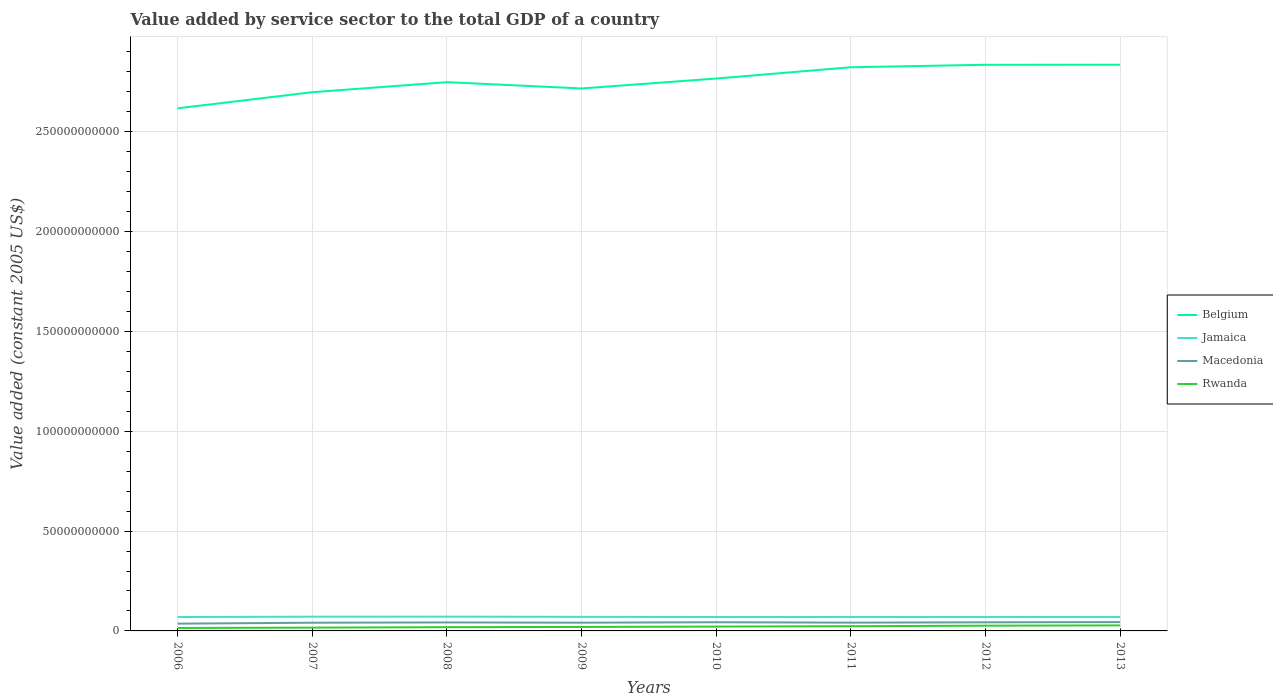Does the line corresponding to Rwanda intersect with the line corresponding to Jamaica?
Offer a very short reply. No. Across all years, what is the maximum value added by service sector in Macedonia?
Make the answer very short. 3.65e+09. In which year was the value added by service sector in Rwanda maximum?
Make the answer very short. 2006. What is the total value added by service sector in Belgium in the graph?
Ensure brevity in your answer.  -1.81e+09. What is the difference between the highest and the second highest value added by service sector in Belgium?
Offer a very short reply. 2.18e+1. What is the difference between two consecutive major ticks on the Y-axis?
Provide a succinct answer. 5.00e+1. Are the values on the major ticks of Y-axis written in scientific E-notation?
Offer a very short reply. No. Does the graph contain grids?
Offer a terse response. Yes. Where does the legend appear in the graph?
Your answer should be very brief. Center right. How many legend labels are there?
Make the answer very short. 4. How are the legend labels stacked?
Your response must be concise. Vertical. What is the title of the graph?
Your response must be concise. Value added by service sector to the total GDP of a country. Does "Least developed countries" appear as one of the legend labels in the graph?
Your response must be concise. No. What is the label or title of the Y-axis?
Make the answer very short. Value added (constant 2005 US$). What is the Value added (constant 2005 US$) of Belgium in 2006?
Offer a terse response. 2.62e+11. What is the Value added (constant 2005 US$) in Jamaica in 2006?
Provide a succinct answer. 6.97e+09. What is the Value added (constant 2005 US$) in Macedonia in 2006?
Keep it short and to the point. 3.65e+09. What is the Value added (constant 2005 US$) in Rwanda in 2006?
Make the answer very short. 1.47e+09. What is the Value added (constant 2005 US$) in Belgium in 2007?
Your answer should be compact. 2.70e+11. What is the Value added (constant 2005 US$) in Jamaica in 2007?
Keep it short and to the point. 7.12e+09. What is the Value added (constant 2005 US$) of Macedonia in 2007?
Your answer should be very brief. 4.11e+09. What is the Value added (constant 2005 US$) of Rwanda in 2007?
Ensure brevity in your answer.  1.65e+09. What is the Value added (constant 2005 US$) in Belgium in 2008?
Ensure brevity in your answer.  2.75e+11. What is the Value added (constant 2005 US$) of Jamaica in 2008?
Make the answer very short. 7.15e+09. What is the Value added (constant 2005 US$) in Macedonia in 2008?
Your answer should be very brief. 4.25e+09. What is the Value added (constant 2005 US$) in Rwanda in 2008?
Your answer should be very brief. 1.88e+09. What is the Value added (constant 2005 US$) of Belgium in 2009?
Ensure brevity in your answer.  2.72e+11. What is the Value added (constant 2005 US$) of Jamaica in 2009?
Your response must be concise. 7.05e+09. What is the Value added (constant 2005 US$) of Macedonia in 2009?
Offer a terse response. 4.13e+09. What is the Value added (constant 2005 US$) of Rwanda in 2009?
Make the answer very short. 1.99e+09. What is the Value added (constant 2005 US$) in Belgium in 2010?
Provide a succinct answer. 2.77e+11. What is the Value added (constant 2005 US$) in Jamaica in 2010?
Your response must be concise. 6.98e+09. What is the Value added (constant 2005 US$) in Macedonia in 2010?
Ensure brevity in your answer.  4.34e+09. What is the Value added (constant 2005 US$) of Rwanda in 2010?
Your response must be concise. 2.17e+09. What is the Value added (constant 2005 US$) in Belgium in 2011?
Your answer should be very brief. 2.82e+11. What is the Value added (constant 2005 US$) of Jamaica in 2011?
Give a very brief answer. 7.00e+09. What is the Value added (constant 2005 US$) in Macedonia in 2011?
Offer a terse response. 4.15e+09. What is the Value added (constant 2005 US$) of Rwanda in 2011?
Provide a succinct answer. 2.35e+09. What is the Value added (constant 2005 US$) of Belgium in 2012?
Your response must be concise. 2.83e+11. What is the Value added (constant 2005 US$) of Jamaica in 2012?
Offer a terse response. 6.99e+09. What is the Value added (constant 2005 US$) of Macedonia in 2012?
Offer a terse response. 4.30e+09. What is the Value added (constant 2005 US$) of Rwanda in 2012?
Your answer should be very brief. 2.63e+09. What is the Value added (constant 2005 US$) of Belgium in 2013?
Provide a succinct answer. 2.84e+11. What is the Value added (constant 2005 US$) of Jamaica in 2013?
Provide a succinct answer. 7.01e+09. What is the Value added (constant 2005 US$) in Macedonia in 2013?
Ensure brevity in your answer.  4.42e+09. What is the Value added (constant 2005 US$) of Rwanda in 2013?
Provide a succinct answer. 2.76e+09. Across all years, what is the maximum Value added (constant 2005 US$) of Belgium?
Ensure brevity in your answer.  2.84e+11. Across all years, what is the maximum Value added (constant 2005 US$) in Jamaica?
Give a very brief answer. 7.15e+09. Across all years, what is the maximum Value added (constant 2005 US$) of Macedonia?
Your answer should be very brief. 4.42e+09. Across all years, what is the maximum Value added (constant 2005 US$) of Rwanda?
Ensure brevity in your answer.  2.76e+09. Across all years, what is the minimum Value added (constant 2005 US$) in Belgium?
Your answer should be very brief. 2.62e+11. Across all years, what is the minimum Value added (constant 2005 US$) in Jamaica?
Offer a terse response. 6.97e+09. Across all years, what is the minimum Value added (constant 2005 US$) of Macedonia?
Make the answer very short. 3.65e+09. Across all years, what is the minimum Value added (constant 2005 US$) of Rwanda?
Your answer should be compact. 1.47e+09. What is the total Value added (constant 2005 US$) of Belgium in the graph?
Give a very brief answer. 2.20e+12. What is the total Value added (constant 2005 US$) in Jamaica in the graph?
Make the answer very short. 5.63e+1. What is the total Value added (constant 2005 US$) in Macedonia in the graph?
Ensure brevity in your answer.  3.34e+1. What is the total Value added (constant 2005 US$) of Rwanda in the graph?
Keep it short and to the point. 1.69e+1. What is the difference between the Value added (constant 2005 US$) of Belgium in 2006 and that in 2007?
Make the answer very short. -8.08e+09. What is the difference between the Value added (constant 2005 US$) of Jamaica in 2006 and that in 2007?
Your answer should be very brief. -1.55e+08. What is the difference between the Value added (constant 2005 US$) of Macedonia in 2006 and that in 2007?
Offer a terse response. -4.63e+08. What is the difference between the Value added (constant 2005 US$) in Rwanda in 2006 and that in 2007?
Provide a short and direct response. -1.78e+08. What is the difference between the Value added (constant 2005 US$) of Belgium in 2006 and that in 2008?
Your response must be concise. -1.31e+1. What is the difference between the Value added (constant 2005 US$) of Jamaica in 2006 and that in 2008?
Keep it short and to the point. -1.85e+08. What is the difference between the Value added (constant 2005 US$) in Macedonia in 2006 and that in 2008?
Provide a succinct answer. -6.05e+08. What is the difference between the Value added (constant 2005 US$) in Rwanda in 2006 and that in 2008?
Offer a very short reply. -4.03e+08. What is the difference between the Value added (constant 2005 US$) in Belgium in 2006 and that in 2009?
Give a very brief answer. -9.95e+09. What is the difference between the Value added (constant 2005 US$) in Jamaica in 2006 and that in 2009?
Offer a terse response. -8.30e+07. What is the difference between the Value added (constant 2005 US$) of Macedonia in 2006 and that in 2009?
Keep it short and to the point. -4.86e+08. What is the difference between the Value added (constant 2005 US$) in Rwanda in 2006 and that in 2009?
Keep it short and to the point. -5.18e+08. What is the difference between the Value added (constant 2005 US$) in Belgium in 2006 and that in 2010?
Make the answer very short. -1.49e+1. What is the difference between the Value added (constant 2005 US$) of Jamaica in 2006 and that in 2010?
Keep it short and to the point. -1.06e+07. What is the difference between the Value added (constant 2005 US$) of Macedonia in 2006 and that in 2010?
Ensure brevity in your answer.  -6.92e+08. What is the difference between the Value added (constant 2005 US$) in Rwanda in 2006 and that in 2010?
Your answer should be very brief. -7.00e+08. What is the difference between the Value added (constant 2005 US$) in Belgium in 2006 and that in 2011?
Keep it short and to the point. -2.06e+1. What is the difference between the Value added (constant 2005 US$) of Jamaica in 2006 and that in 2011?
Your response must be concise. -2.85e+07. What is the difference between the Value added (constant 2005 US$) of Macedonia in 2006 and that in 2011?
Offer a terse response. -4.98e+08. What is the difference between the Value added (constant 2005 US$) in Rwanda in 2006 and that in 2011?
Offer a terse response. -8.80e+08. What is the difference between the Value added (constant 2005 US$) in Belgium in 2006 and that in 2012?
Make the answer very short. -2.18e+1. What is the difference between the Value added (constant 2005 US$) of Jamaica in 2006 and that in 2012?
Offer a terse response. -2.44e+07. What is the difference between the Value added (constant 2005 US$) of Macedonia in 2006 and that in 2012?
Your answer should be compact. -6.55e+08. What is the difference between the Value added (constant 2005 US$) of Rwanda in 2006 and that in 2012?
Offer a terse response. -1.15e+09. What is the difference between the Value added (constant 2005 US$) in Belgium in 2006 and that in 2013?
Provide a short and direct response. -2.18e+1. What is the difference between the Value added (constant 2005 US$) in Jamaica in 2006 and that in 2013?
Offer a very short reply. -3.92e+07. What is the difference between the Value added (constant 2005 US$) of Macedonia in 2006 and that in 2013?
Your answer should be very brief. -7.69e+08. What is the difference between the Value added (constant 2005 US$) in Rwanda in 2006 and that in 2013?
Give a very brief answer. -1.29e+09. What is the difference between the Value added (constant 2005 US$) of Belgium in 2007 and that in 2008?
Offer a very short reply. -5.02e+09. What is the difference between the Value added (constant 2005 US$) in Jamaica in 2007 and that in 2008?
Offer a terse response. -2.92e+07. What is the difference between the Value added (constant 2005 US$) of Macedonia in 2007 and that in 2008?
Offer a very short reply. -1.43e+08. What is the difference between the Value added (constant 2005 US$) in Rwanda in 2007 and that in 2008?
Your answer should be very brief. -2.25e+08. What is the difference between the Value added (constant 2005 US$) of Belgium in 2007 and that in 2009?
Make the answer very short. -1.87e+09. What is the difference between the Value added (constant 2005 US$) in Jamaica in 2007 and that in 2009?
Your answer should be compact. 7.25e+07. What is the difference between the Value added (constant 2005 US$) in Macedonia in 2007 and that in 2009?
Ensure brevity in your answer.  -2.30e+07. What is the difference between the Value added (constant 2005 US$) in Rwanda in 2007 and that in 2009?
Give a very brief answer. -3.41e+08. What is the difference between the Value added (constant 2005 US$) of Belgium in 2007 and that in 2010?
Keep it short and to the point. -6.84e+09. What is the difference between the Value added (constant 2005 US$) in Jamaica in 2007 and that in 2010?
Your answer should be very brief. 1.45e+08. What is the difference between the Value added (constant 2005 US$) of Macedonia in 2007 and that in 2010?
Provide a succinct answer. -2.29e+08. What is the difference between the Value added (constant 2005 US$) of Rwanda in 2007 and that in 2010?
Provide a succinct answer. -5.22e+08. What is the difference between the Value added (constant 2005 US$) in Belgium in 2007 and that in 2011?
Your answer should be very brief. -1.25e+1. What is the difference between the Value added (constant 2005 US$) in Jamaica in 2007 and that in 2011?
Your answer should be very brief. 1.27e+08. What is the difference between the Value added (constant 2005 US$) in Macedonia in 2007 and that in 2011?
Offer a terse response. -3.58e+07. What is the difference between the Value added (constant 2005 US$) in Rwanda in 2007 and that in 2011?
Your response must be concise. -7.03e+08. What is the difference between the Value added (constant 2005 US$) in Belgium in 2007 and that in 2012?
Make the answer very short. -1.37e+1. What is the difference between the Value added (constant 2005 US$) in Jamaica in 2007 and that in 2012?
Provide a short and direct response. 1.31e+08. What is the difference between the Value added (constant 2005 US$) in Macedonia in 2007 and that in 2012?
Provide a succinct answer. -1.93e+08. What is the difference between the Value added (constant 2005 US$) in Rwanda in 2007 and that in 2012?
Offer a very short reply. -9.75e+08. What is the difference between the Value added (constant 2005 US$) of Belgium in 2007 and that in 2013?
Give a very brief answer. -1.38e+1. What is the difference between the Value added (constant 2005 US$) of Jamaica in 2007 and that in 2013?
Offer a terse response. 1.16e+08. What is the difference between the Value added (constant 2005 US$) of Macedonia in 2007 and that in 2013?
Offer a very short reply. -3.06e+08. What is the difference between the Value added (constant 2005 US$) in Rwanda in 2007 and that in 2013?
Your answer should be compact. -1.11e+09. What is the difference between the Value added (constant 2005 US$) in Belgium in 2008 and that in 2009?
Provide a short and direct response. 3.15e+09. What is the difference between the Value added (constant 2005 US$) of Jamaica in 2008 and that in 2009?
Provide a succinct answer. 1.02e+08. What is the difference between the Value added (constant 2005 US$) of Macedonia in 2008 and that in 2009?
Keep it short and to the point. 1.20e+08. What is the difference between the Value added (constant 2005 US$) of Rwanda in 2008 and that in 2009?
Offer a very short reply. -1.16e+08. What is the difference between the Value added (constant 2005 US$) in Belgium in 2008 and that in 2010?
Provide a short and direct response. -1.81e+09. What is the difference between the Value added (constant 2005 US$) of Jamaica in 2008 and that in 2010?
Your answer should be compact. 1.74e+08. What is the difference between the Value added (constant 2005 US$) of Macedonia in 2008 and that in 2010?
Offer a very short reply. -8.65e+07. What is the difference between the Value added (constant 2005 US$) of Rwanda in 2008 and that in 2010?
Offer a very short reply. -2.97e+08. What is the difference between the Value added (constant 2005 US$) of Belgium in 2008 and that in 2011?
Your response must be concise. -7.47e+09. What is the difference between the Value added (constant 2005 US$) in Jamaica in 2008 and that in 2011?
Your answer should be very brief. 1.56e+08. What is the difference between the Value added (constant 2005 US$) of Macedonia in 2008 and that in 2011?
Provide a succinct answer. 1.07e+08. What is the difference between the Value added (constant 2005 US$) of Rwanda in 2008 and that in 2011?
Offer a terse response. -4.78e+08. What is the difference between the Value added (constant 2005 US$) of Belgium in 2008 and that in 2012?
Keep it short and to the point. -8.71e+09. What is the difference between the Value added (constant 2005 US$) of Jamaica in 2008 and that in 2012?
Provide a succinct answer. 1.60e+08. What is the difference between the Value added (constant 2005 US$) of Macedonia in 2008 and that in 2012?
Your answer should be compact. -5.01e+07. What is the difference between the Value added (constant 2005 US$) in Rwanda in 2008 and that in 2012?
Offer a very short reply. -7.50e+08. What is the difference between the Value added (constant 2005 US$) of Belgium in 2008 and that in 2013?
Make the answer very short. -8.73e+09. What is the difference between the Value added (constant 2005 US$) in Jamaica in 2008 and that in 2013?
Give a very brief answer. 1.45e+08. What is the difference between the Value added (constant 2005 US$) of Macedonia in 2008 and that in 2013?
Your response must be concise. -1.63e+08. What is the difference between the Value added (constant 2005 US$) of Rwanda in 2008 and that in 2013?
Your answer should be compact. -8.87e+08. What is the difference between the Value added (constant 2005 US$) of Belgium in 2009 and that in 2010?
Provide a short and direct response. -4.96e+09. What is the difference between the Value added (constant 2005 US$) in Jamaica in 2009 and that in 2010?
Your response must be concise. 7.23e+07. What is the difference between the Value added (constant 2005 US$) of Macedonia in 2009 and that in 2010?
Your response must be concise. -2.06e+08. What is the difference between the Value added (constant 2005 US$) in Rwanda in 2009 and that in 2010?
Provide a short and direct response. -1.82e+08. What is the difference between the Value added (constant 2005 US$) in Belgium in 2009 and that in 2011?
Offer a terse response. -1.06e+1. What is the difference between the Value added (constant 2005 US$) in Jamaica in 2009 and that in 2011?
Give a very brief answer. 5.44e+07. What is the difference between the Value added (constant 2005 US$) in Macedonia in 2009 and that in 2011?
Give a very brief answer. -1.28e+07. What is the difference between the Value added (constant 2005 US$) of Rwanda in 2009 and that in 2011?
Keep it short and to the point. -3.62e+08. What is the difference between the Value added (constant 2005 US$) in Belgium in 2009 and that in 2012?
Provide a succinct answer. -1.19e+1. What is the difference between the Value added (constant 2005 US$) in Jamaica in 2009 and that in 2012?
Offer a terse response. 5.85e+07. What is the difference between the Value added (constant 2005 US$) of Macedonia in 2009 and that in 2012?
Ensure brevity in your answer.  -1.70e+08. What is the difference between the Value added (constant 2005 US$) of Rwanda in 2009 and that in 2012?
Make the answer very short. -6.34e+08. What is the difference between the Value added (constant 2005 US$) in Belgium in 2009 and that in 2013?
Your answer should be very brief. -1.19e+1. What is the difference between the Value added (constant 2005 US$) in Jamaica in 2009 and that in 2013?
Your response must be concise. 4.37e+07. What is the difference between the Value added (constant 2005 US$) in Macedonia in 2009 and that in 2013?
Ensure brevity in your answer.  -2.83e+08. What is the difference between the Value added (constant 2005 US$) of Rwanda in 2009 and that in 2013?
Offer a very short reply. -7.71e+08. What is the difference between the Value added (constant 2005 US$) in Belgium in 2010 and that in 2011?
Make the answer very short. -5.66e+09. What is the difference between the Value added (constant 2005 US$) in Jamaica in 2010 and that in 2011?
Keep it short and to the point. -1.79e+07. What is the difference between the Value added (constant 2005 US$) of Macedonia in 2010 and that in 2011?
Ensure brevity in your answer.  1.93e+08. What is the difference between the Value added (constant 2005 US$) of Rwanda in 2010 and that in 2011?
Provide a succinct answer. -1.80e+08. What is the difference between the Value added (constant 2005 US$) of Belgium in 2010 and that in 2012?
Your response must be concise. -6.89e+09. What is the difference between the Value added (constant 2005 US$) of Jamaica in 2010 and that in 2012?
Provide a succinct answer. -1.38e+07. What is the difference between the Value added (constant 2005 US$) of Macedonia in 2010 and that in 2012?
Make the answer very short. 3.64e+07. What is the difference between the Value added (constant 2005 US$) in Rwanda in 2010 and that in 2012?
Provide a succinct answer. -4.53e+08. What is the difference between the Value added (constant 2005 US$) in Belgium in 2010 and that in 2013?
Your response must be concise. -6.91e+09. What is the difference between the Value added (constant 2005 US$) in Jamaica in 2010 and that in 2013?
Your response must be concise. -2.86e+07. What is the difference between the Value added (constant 2005 US$) of Macedonia in 2010 and that in 2013?
Keep it short and to the point. -7.68e+07. What is the difference between the Value added (constant 2005 US$) of Rwanda in 2010 and that in 2013?
Your answer should be compact. -5.89e+08. What is the difference between the Value added (constant 2005 US$) in Belgium in 2011 and that in 2012?
Offer a very short reply. -1.23e+09. What is the difference between the Value added (constant 2005 US$) of Jamaica in 2011 and that in 2012?
Make the answer very short. 4.11e+06. What is the difference between the Value added (constant 2005 US$) of Macedonia in 2011 and that in 2012?
Keep it short and to the point. -1.57e+08. What is the difference between the Value added (constant 2005 US$) in Rwanda in 2011 and that in 2012?
Ensure brevity in your answer.  -2.72e+08. What is the difference between the Value added (constant 2005 US$) in Belgium in 2011 and that in 2013?
Offer a very short reply. -1.25e+09. What is the difference between the Value added (constant 2005 US$) of Jamaica in 2011 and that in 2013?
Provide a short and direct response. -1.07e+07. What is the difference between the Value added (constant 2005 US$) in Macedonia in 2011 and that in 2013?
Your response must be concise. -2.70e+08. What is the difference between the Value added (constant 2005 US$) in Rwanda in 2011 and that in 2013?
Your answer should be very brief. -4.09e+08. What is the difference between the Value added (constant 2005 US$) in Belgium in 2012 and that in 2013?
Provide a short and direct response. -2.04e+07. What is the difference between the Value added (constant 2005 US$) of Jamaica in 2012 and that in 2013?
Your response must be concise. -1.48e+07. What is the difference between the Value added (constant 2005 US$) of Macedonia in 2012 and that in 2013?
Ensure brevity in your answer.  -1.13e+08. What is the difference between the Value added (constant 2005 US$) of Rwanda in 2012 and that in 2013?
Your response must be concise. -1.37e+08. What is the difference between the Value added (constant 2005 US$) of Belgium in 2006 and the Value added (constant 2005 US$) of Jamaica in 2007?
Offer a very short reply. 2.55e+11. What is the difference between the Value added (constant 2005 US$) of Belgium in 2006 and the Value added (constant 2005 US$) of Macedonia in 2007?
Offer a terse response. 2.58e+11. What is the difference between the Value added (constant 2005 US$) of Belgium in 2006 and the Value added (constant 2005 US$) of Rwanda in 2007?
Keep it short and to the point. 2.60e+11. What is the difference between the Value added (constant 2005 US$) in Jamaica in 2006 and the Value added (constant 2005 US$) in Macedonia in 2007?
Your response must be concise. 2.86e+09. What is the difference between the Value added (constant 2005 US$) of Jamaica in 2006 and the Value added (constant 2005 US$) of Rwanda in 2007?
Give a very brief answer. 5.32e+09. What is the difference between the Value added (constant 2005 US$) in Macedonia in 2006 and the Value added (constant 2005 US$) in Rwanda in 2007?
Make the answer very short. 2.00e+09. What is the difference between the Value added (constant 2005 US$) of Belgium in 2006 and the Value added (constant 2005 US$) of Jamaica in 2008?
Make the answer very short. 2.55e+11. What is the difference between the Value added (constant 2005 US$) of Belgium in 2006 and the Value added (constant 2005 US$) of Macedonia in 2008?
Offer a terse response. 2.57e+11. What is the difference between the Value added (constant 2005 US$) in Belgium in 2006 and the Value added (constant 2005 US$) in Rwanda in 2008?
Offer a terse response. 2.60e+11. What is the difference between the Value added (constant 2005 US$) of Jamaica in 2006 and the Value added (constant 2005 US$) of Macedonia in 2008?
Your answer should be very brief. 2.72e+09. What is the difference between the Value added (constant 2005 US$) in Jamaica in 2006 and the Value added (constant 2005 US$) in Rwanda in 2008?
Provide a succinct answer. 5.09e+09. What is the difference between the Value added (constant 2005 US$) in Macedonia in 2006 and the Value added (constant 2005 US$) in Rwanda in 2008?
Offer a very short reply. 1.77e+09. What is the difference between the Value added (constant 2005 US$) of Belgium in 2006 and the Value added (constant 2005 US$) of Jamaica in 2009?
Offer a very short reply. 2.55e+11. What is the difference between the Value added (constant 2005 US$) in Belgium in 2006 and the Value added (constant 2005 US$) in Macedonia in 2009?
Keep it short and to the point. 2.58e+11. What is the difference between the Value added (constant 2005 US$) of Belgium in 2006 and the Value added (constant 2005 US$) of Rwanda in 2009?
Offer a terse response. 2.60e+11. What is the difference between the Value added (constant 2005 US$) in Jamaica in 2006 and the Value added (constant 2005 US$) in Macedonia in 2009?
Keep it short and to the point. 2.84e+09. What is the difference between the Value added (constant 2005 US$) in Jamaica in 2006 and the Value added (constant 2005 US$) in Rwanda in 2009?
Give a very brief answer. 4.98e+09. What is the difference between the Value added (constant 2005 US$) in Macedonia in 2006 and the Value added (constant 2005 US$) in Rwanda in 2009?
Make the answer very short. 1.65e+09. What is the difference between the Value added (constant 2005 US$) in Belgium in 2006 and the Value added (constant 2005 US$) in Jamaica in 2010?
Offer a terse response. 2.55e+11. What is the difference between the Value added (constant 2005 US$) in Belgium in 2006 and the Value added (constant 2005 US$) in Macedonia in 2010?
Your answer should be very brief. 2.57e+11. What is the difference between the Value added (constant 2005 US$) in Belgium in 2006 and the Value added (constant 2005 US$) in Rwanda in 2010?
Offer a very short reply. 2.60e+11. What is the difference between the Value added (constant 2005 US$) in Jamaica in 2006 and the Value added (constant 2005 US$) in Macedonia in 2010?
Keep it short and to the point. 2.63e+09. What is the difference between the Value added (constant 2005 US$) in Jamaica in 2006 and the Value added (constant 2005 US$) in Rwanda in 2010?
Offer a very short reply. 4.79e+09. What is the difference between the Value added (constant 2005 US$) of Macedonia in 2006 and the Value added (constant 2005 US$) of Rwanda in 2010?
Give a very brief answer. 1.47e+09. What is the difference between the Value added (constant 2005 US$) in Belgium in 2006 and the Value added (constant 2005 US$) in Jamaica in 2011?
Give a very brief answer. 2.55e+11. What is the difference between the Value added (constant 2005 US$) in Belgium in 2006 and the Value added (constant 2005 US$) in Macedonia in 2011?
Provide a short and direct response. 2.58e+11. What is the difference between the Value added (constant 2005 US$) of Belgium in 2006 and the Value added (constant 2005 US$) of Rwanda in 2011?
Your answer should be very brief. 2.59e+11. What is the difference between the Value added (constant 2005 US$) in Jamaica in 2006 and the Value added (constant 2005 US$) in Macedonia in 2011?
Ensure brevity in your answer.  2.82e+09. What is the difference between the Value added (constant 2005 US$) of Jamaica in 2006 and the Value added (constant 2005 US$) of Rwanda in 2011?
Offer a very short reply. 4.61e+09. What is the difference between the Value added (constant 2005 US$) in Macedonia in 2006 and the Value added (constant 2005 US$) in Rwanda in 2011?
Your answer should be very brief. 1.29e+09. What is the difference between the Value added (constant 2005 US$) in Belgium in 2006 and the Value added (constant 2005 US$) in Jamaica in 2012?
Your response must be concise. 2.55e+11. What is the difference between the Value added (constant 2005 US$) in Belgium in 2006 and the Value added (constant 2005 US$) in Macedonia in 2012?
Keep it short and to the point. 2.57e+11. What is the difference between the Value added (constant 2005 US$) in Belgium in 2006 and the Value added (constant 2005 US$) in Rwanda in 2012?
Provide a succinct answer. 2.59e+11. What is the difference between the Value added (constant 2005 US$) of Jamaica in 2006 and the Value added (constant 2005 US$) of Macedonia in 2012?
Ensure brevity in your answer.  2.67e+09. What is the difference between the Value added (constant 2005 US$) of Jamaica in 2006 and the Value added (constant 2005 US$) of Rwanda in 2012?
Ensure brevity in your answer.  4.34e+09. What is the difference between the Value added (constant 2005 US$) of Macedonia in 2006 and the Value added (constant 2005 US$) of Rwanda in 2012?
Give a very brief answer. 1.02e+09. What is the difference between the Value added (constant 2005 US$) in Belgium in 2006 and the Value added (constant 2005 US$) in Jamaica in 2013?
Keep it short and to the point. 2.55e+11. What is the difference between the Value added (constant 2005 US$) of Belgium in 2006 and the Value added (constant 2005 US$) of Macedonia in 2013?
Offer a very short reply. 2.57e+11. What is the difference between the Value added (constant 2005 US$) in Belgium in 2006 and the Value added (constant 2005 US$) in Rwanda in 2013?
Keep it short and to the point. 2.59e+11. What is the difference between the Value added (constant 2005 US$) of Jamaica in 2006 and the Value added (constant 2005 US$) of Macedonia in 2013?
Offer a very short reply. 2.55e+09. What is the difference between the Value added (constant 2005 US$) in Jamaica in 2006 and the Value added (constant 2005 US$) in Rwanda in 2013?
Provide a short and direct response. 4.21e+09. What is the difference between the Value added (constant 2005 US$) in Macedonia in 2006 and the Value added (constant 2005 US$) in Rwanda in 2013?
Ensure brevity in your answer.  8.84e+08. What is the difference between the Value added (constant 2005 US$) of Belgium in 2007 and the Value added (constant 2005 US$) of Jamaica in 2008?
Keep it short and to the point. 2.63e+11. What is the difference between the Value added (constant 2005 US$) in Belgium in 2007 and the Value added (constant 2005 US$) in Macedonia in 2008?
Ensure brevity in your answer.  2.65e+11. What is the difference between the Value added (constant 2005 US$) of Belgium in 2007 and the Value added (constant 2005 US$) of Rwanda in 2008?
Provide a short and direct response. 2.68e+11. What is the difference between the Value added (constant 2005 US$) in Jamaica in 2007 and the Value added (constant 2005 US$) in Macedonia in 2008?
Your answer should be compact. 2.87e+09. What is the difference between the Value added (constant 2005 US$) of Jamaica in 2007 and the Value added (constant 2005 US$) of Rwanda in 2008?
Provide a succinct answer. 5.25e+09. What is the difference between the Value added (constant 2005 US$) in Macedonia in 2007 and the Value added (constant 2005 US$) in Rwanda in 2008?
Offer a terse response. 2.23e+09. What is the difference between the Value added (constant 2005 US$) of Belgium in 2007 and the Value added (constant 2005 US$) of Jamaica in 2009?
Give a very brief answer. 2.63e+11. What is the difference between the Value added (constant 2005 US$) in Belgium in 2007 and the Value added (constant 2005 US$) in Macedonia in 2009?
Offer a terse response. 2.66e+11. What is the difference between the Value added (constant 2005 US$) in Belgium in 2007 and the Value added (constant 2005 US$) in Rwanda in 2009?
Keep it short and to the point. 2.68e+11. What is the difference between the Value added (constant 2005 US$) in Jamaica in 2007 and the Value added (constant 2005 US$) in Macedonia in 2009?
Offer a very short reply. 2.99e+09. What is the difference between the Value added (constant 2005 US$) of Jamaica in 2007 and the Value added (constant 2005 US$) of Rwanda in 2009?
Give a very brief answer. 5.13e+09. What is the difference between the Value added (constant 2005 US$) of Macedonia in 2007 and the Value added (constant 2005 US$) of Rwanda in 2009?
Ensure brevity in your answer.  2.12e+09. What is the difference between the Value added (constant 2005 US$) in Belgium in 2007 and the Value added (constant 2005 US$) in Jamaica in 2010?
Make the answer very short. 2.63e+11. What is the difference between the Value added (constant 2005 US$) in Belgium in 2007 and the Value added (constant 2005 US$) in Macedonia in 2010?
Your response must be concise. 2.65e+11. What is the difference between the Value added (constant 2005 US$) of Belgium in 2007 and the Value added (constant 2005 US$) of Rwanda in 2010?
Ensure brevity in your answer.  2.68e+11. What is the difference between the Value added (constant 2005 US$) in Jamaica in 2007 and the Value added (constant 2005 US$) in Macedonia in 2010?
Make the answer very short. 2.78e+09. What is the difference between the Value added (constant 2005 US$) in Jamaica in 2007 and the Value added (constant 2005 US$) in Rwanda in 2010?
Your answer should be compact. 4.95e+09. What is the difference between the Value added (constant 2005 US$) in Macedonia in 2007 and the Value added (constant 2005 US$) in Rwanda in 2010?
Provide a short and direct response. 1.94e+09. What is the difference between the Value added (constant 2005 US$) in Belgium in 2007 and the Value added (constant 2005 US$) in Jamaica in 2011?
Ensure brevity in your answer.  2.63e+11. What is the difference between the Value added (constant 2005 US$) in Belgium in 2007 and the Value added (constant 2005 US$) in Macedonia in 2011?
Your answer should be very brief. 2.66e+11. What is the difference between the Value added (constant 2005 US$) in Belgium in 2007 and the Value added (constant 2005 US$) in Rwanda in 2011?
Your response must be concise. 2.67e+11. What is the difference between the Value added (constant 2005 US$) in Jamaica in 2007 and the Value added (constant 2005 US$) in Macedonia in 2011?
Provide a succinct answer. 2.98e+09. What is the difference between the Value added (constant 2005 US$) of Jamaica in 2007 and the Value added (constant 2005 US$) of Rwanda in 2011?
Ensure brevity in your answer.  4.77e+09. What is the difference between the Value added (constant 2005 US$) of Macedonia in 2007 and the Value added (constant 2005 US$) of Rwanda in 2011?
Ensure brevity in your answer.  1.76e+09. What is the difference between the Value added (constant 2005 US$) of Belgium in 2007 and the Value added (constant 2005 US$) of Jamaica in 2012?
Provide a succinct answer. 2.63e+11. What is the difference between the Value added (constant 2005 US$) of Belgium in 2007 and the Value added (constant 2005 US$) of Macedonia in 2012?
Your response must be concise. 2.65e+11. What is the difference between the Value added (constant 2005 US$) of Belgium in 2007 and the Value added (constant 2005 US$) of Rwanda in 2012?
Your response must be concise. 2.67e+11. What is the difference between the Value added (constant 2005 US$) of Jamaica in 2007 and the Value added (constant 2005 US$) of Macedonia in 2012?
Your answer should be compact. 2.82e+09. What is the difference between the Value added (constant 2005 US$) of Jamaica in 2007 and the Value added (constant 2005 US$) of Rwanda in 2012?
Your response must be concise. 4.50e+09. What is the difference between the Value added (constant 2005 US$) of Macedonia in 2007 and the Value added (constant 2005 US$) of Rwanda in 2012?
Your answer should be compact. 1.48e+09. What is the difference between the Value added (constant 2005 US$) in Belgium in 2007 and the Value added (constant 2005 US$) in Jamaica in 2013?
Give a very brief answer. 2.63e+11. What is the difference between the Value added (constant 2005 US$) in Belgium in 2007 and the Value added (constant 2005 US$) in Macedonia in 2013?
Ensure brevity in your answer.  2.65e+11. What is the difference between the Value added (constant 2005 US$) of Belgium in 2007 and the Value added (constant 2005 US$) of Rwanda in 2013?
Make the answer very short. 2.67e+11. What is the difference between the Value added (constant 2005 US$) in Jamaica in 2007 and the Value added (constant 2005 US$) in Macedonia in 2013?
Give a very brief answer. 2.71e+09. What is the difference between the Value added (constant 2005 US$) in Jamaica in 2007 and the Value added (constant 2005 US$) in Rwanda in 2013?
Make the answer very short. 4.36e+09. What is the difference between the Value added (constant 2005 US$) in Macedonia in 2007 and the Value added (constant 2005 US$) in Rwanda in 2013?
Your answer should be very brief. 1.35e+09. What is the difference between the Value added (constant 2005 US$) of Belgium in 2008 and the Value added (constant 2005 US$) of Jamaica in 2009?
Keep it short and to the point. 2.68e+11. What is the difference between the Value added (constant 2005 US$) of Belgium in 2008 and the Value added (constant 2005 US$) of Macedonia in 2009?
Your answer should be very brief. 2.71e+11. What is the difference between the Value added (constant 2005 US$) of Belgium in 2008 and the Value added (constant 2005 US$) of Rwanda in 2009?
Your answer should be compact. 2.73e+11. What is the difference between the Value added (constant 2005 US$) in Jamaica in 2008 and the Value added (constant 2005 US$) in Macedonia in 2009?
Your response must be concise. 3.02e+09. What is the difference between the Value added (constant 2005 US$) in Jamaica in 2008 and the Value added (constant 2005 US$) in Rwanda in 2009?
Your answer should be very brief. 5.16e+09. What is the difference between the Value added (constant 2005 US$) in Macedonia in 2008 and the Value added (constant 2005 US$) in Rwanda in 2009?
Your answer should be very brief. 2.26e+09. What is the difference between the Value added (constant 2005 US$) of Belgium in 2008 and the Value added (constant 2005 US$) of Jamaica in 2010?
Give a very brief answer. 2.68e+11. What is the difference between the Value added (constant 2005 US$) in Belgium in 2008 and the Value added (constant 2005 US$) in Macedonia in 2010?
Your answer should be very brief. 2.70e+11. What is the difference between the Value added (constant 2005 US$) in Belgium in 2008 and the Value added (constant 2005 US$) in Rwanda in 2010?
Ensure brevity in your answer.  2.73e+11. What is the difference between the Value added (constant 2005 US$) in Jamaica in 2008 and the Value added (constant 2005 US$) in Macedonia in 2010?
Offer a terse response. 2.81e+09. What is the difference between the Value added (constant 2005 US$) of Jamaica in 2008 and the Value added (constant 2005 US$) of Rwanda in 2010?
Your response must be concise. 4.98e+09. What is the difference between the Value added (constant 2005 US$) in Macedonia in 2008 and the Value added (constant 2005 US$) in Rwanda in 2010?
Give a very brief answer. 2.08e+09. What is the difference between the Value added (constant 2005 US$) of Belgium in 2008 and the Value added (constant 2005 US$) of Jamaica in 2011?
Your answer should be very brief. 2.68e+11. What is the difference between the Value added (constant 2005 US$) of Belgium in 2008 and the Value added (constant 2005 US$) of Macedonia in 2011?
Provide a succinct answer. 2.71e+11. What is the difference between the Value added (constant 2005 US$) in Belgium in 2008 and the Value added (constant 2005 US$) in Rwanda in 2011?
Provide a succinct answer. 2.72e+11. What is the difference between the Value added (constant 2005 US$) of Jamaica in 2008 and the Value added (constant 2005 US$) of Macedonia in 2011?
Offer a very short reply. 3.01e+09. What is the difference between the Value added (constant 2005 US$) in Jamaica in 2008 and the Value added (constant 2005 US$) in Rwanda in 2011?
Give a very brief answer. 4.80e+09. What is the difference between the Value added (constant 2005 US$) of Macedonia in 2008 and the Value added (constant 2005 US$) of Rwanda in 2011?
Provide a succinct answer. 1.90e+09. What is the difference between the Value added (constant 2005 US$) in Belgium in 2008 and the Value added (constant 2005 US$) in Jamaica in 2012?
Your answer should be compact. 2.68e+11. What is the difference between the Value added (constant 2005 US$) of Belgium in 2008 and the Value added (constant 2005 US$) of Macedonia in 2012?
Ensure brevity in your answer.  2.70e+11. What is the difference between the Value added (constant 2005 US$) in Belgium in 2008 and the Value added (constant 2005 US$) in Rwanda in 2012?
Provide a short and direct response. 2.72e+11. What is the difference between the Value added (constant 2005 US$) of Jamaica in 2008 and the Value added (constant 2005 US$) of Macedonia in 2012?
Offer a very short reply. 2.85e+09. What is the difference between the Value added (constant 2005 US$) of Jamaica in 2008 and the Value added (constant 2005 US$) of Rwanda in 2012?
Your answer should be very brief. 4.53e+09. What is the difference between the Value added (constant 2005 US$) in Macedonia in 2008 and the Value added (constant 2005 US$) in Rwanda in 2012?
Ensure brevity in your answer.  1.63e+09. What is the difference between the Value added (constant 2005 US$) in Belgium in 2008 and the Value added (constant 2005 US$) in Jamaica in 2013?
Provide a succinct answer. 2.68e+11. What is the difference between the Value added (constant 2005 US$) of Belgium in 2008 and the Value added (constant 2005 US$) of Macedonia in 2013?
Your response must be concise. 2.70e+11. What is the difference between the Value added (constant 2005 US$) of Belgium in 2008 and the Value added (constant 2005 US$) of Rwanda in 2013?
Make the answer very short. 2.72e+11. What is the difference between the Value added (constant 2005 US$) of Jamaica in 2008 and the Value added (constant 2005 US$) of Macedonia in 2013?
Ensure brevity in your answer.  2.74e+09. What is the difference between the Value added (constant 2005 US$) of Jamaica in 2008 and the Value added (constant 2005 US$) of Rwanda in 2013?
Offer a terse response. 4.39e+09. What is the difference between the Value added (constant 2005 US$) in Macedonia in 2008 and the Value added (constant 2005 US$) in Rwanda in 2013?
Make the answer very short. 1.49e+09. What is the difference between the Value added (constant 2005 US$) in Belgium in 2009 and the Value added (constant 2005 US$) in Jamaica in 2010?
Ensure brevity in your answer.  2.65e+11. What is the difference between the Value added (constant 2005 US$) of Belgium in 2009 and the Value added (constant 2005 US$) of Macedonia in 2010?
Offer a terse response. 2.67e+11. What is the difference between the Value added (constant 2005 US$) of Belgium in 2009 and the Value added (constant 2005 US$) of Rwanda in 2010?
Give a very brief answer. 2.69e+11. What is the difference between the Value added (constant 2005 US$) of Jamaica in 2009 and the Value added (constant 2005 US$) of Macedonia in 2010?
Your answer should be compact. 2.71e+09. What is the difference between the Value added (constant 2005 US$) of Jamaica in 2009 and the Value added (constant 2005 US$) of Rwanda in 2010?
Offer a very short reply. 4.88e+09. What is the difference between the Value added (constant 2005 US$) in Macedonia in 2009 and the Value added (constant 2005 US$) in Rwanda in 2010?
Ensure brevity in your answer.  1.96e+09. What is the difference between the Value added (constant 2005 US$) of Belgium in 2009 and the Value added (constant 2005 US$) of Jamaica in 2011?
Make the answer very short. 2.65e+11. What is the difference between the Value added (constant 2005 US$) of Belgium in 2009 and the Value added (constant 2005 US$) of Macedonia in 2011?
Give a very brief answer. 2.67e+11. What is the difference between the Value added (constant 2005 US$) of Belgium in 2009 and the Value added (constant 2005 US$) of Rwanda in 2011?
Your answer should be very brief. 2.69e+11. What is the difference between the Value added (constant 2005 US$) of Jamaica in 2009 and the Value added (constant 2005 US$) of Macedonia in 2011?
Give a very brief answer. 2.91e+09. What is the difference between the Value added (constant 2005 US$) in Jamaica in 2009 and the Value added (constant 2005 US$) in Rwanda in 2011?
Make the answer very short. 4.70e+09. What is the difference between the Value added (constant 2005 US$) in Macedonia in 2009 and the Value added (constant 2005 US$) in Rwanda in 2011?
Provide a short and direct response. 1.78e+09. What is the difference between the Value added (constant 2005 US$) of Belgium in 2009 and the Value added (constant 2005 US$) of Jamaica in 2012?
Make the answer very short. 2.65e+11. What is the difference between the Value added (constant 2005 US$) of Belgium in 2009 and the Value added (constant 2005 US$) of Macedonia in 2012?
Your answer should be very brief. 2.67e+11. What is the difference between the Value added (constant 2005 US$) of Belgium in 2009 and the Value added (constant 2005 US$) of Rwanda in 2012?
Ensure brevity in your answer.  2.69e+11. What is the difference between the Value added (constant 2005 US$) of Jamaica in 2009 and the Value added (constant 2005 US$) of Macedonia in 2012?
Give a very brief answer. 2.75e+09. What is the difference between the Value added (constant 2005 US$) of Jamaica in 2009 and the Value added (constant 2005 US$) of Rwanda in 2012?
Make the answer very short. 4.42e+09. What is the difference between the Value added (constant 2005 US$) in Macedonia in 2009 and the Value added (constant 2005 US$) in Rwanda in 2012?
Offer a very short reply. 1.51e+09. What is the difference between the Value added (constant 2005 US$) in Belgium in 2009 and the Value added (constant 2005 US$) in Jamaica in 2013?
Make the answer very short. 2.65e+11. What is the difference between the Value added (constant 2005 US$) in Belgium in 2009 and the Value added (constant 2005 US$) in Macedonia in 2013?
Ensure brevity in your answer.  2.67e+11. What is the difference between the Value added (constant 2005 US$) of Belgium in 2009 and the Value added (constant 2005 US$) of Rwanda in 2013?
Your answer should be very brief. 2.69e+11. What is the difference between the Value added (constant 2005 US$) in Jamaica in 2009 and the Value added (constant 2005 US$) in Macedonia in 2013?
Offer a very short reply. 2.64e+09. What is the difference between the Value added (constant 2005 US$) of Jamaica in 2009 and the Value added (constant 2005 US$) of Rwanda in 2013?
Ensure brevity in your answer.  4.29e+09. What is the difference between the Value added (constant 2005 US$) of Macedonia in 2009 and the Value added (constant 2005 US$) of Rwanda in 2013?
Your answer should be very brief. 1.37e+09. What is the difference between the Value added (constant 2005 US$) in Belgium in 2010 and the Value added (constant 2005 US$) in Jamaica in 2011?
Offer a terse response. 2.70e+11. What is the difference between the Value added (constant 2005 US$) in Belgium in 2010 and the Value added (constant 2005 US$) in Macedonia in 2011?
Offer a very short reply. 2.72e+11. What is the difference between the Value added (constant 2005 US$) of Belgium in 2010 and the Value added (constant 2005 US$) of Rwanda in 2011?
Your response must be concise. 2.74e+11. What is the difference between the Value added (constant 2005 US$) in Jamaica in 2010 and the Value added (constant 2005 US$) in Macedonia in 2011?
Your answer should be very brief. 2.83e+09. What is the difference between the Value added (constant 2005 US$) in Jamaica in 2010 and the Value added (constant 2005 US$) in Rwanda in 2011?
Provide a short and direct response. 4.62e+09. What is the difference between the Value added (constant 2005 US$) in Macedonia in 2010 and the Value added (constant 2005 US$) in Rwanda in 2011?
Your answer should be very brief. 1.98e+09. What is the difference between the Value added (constant 2005 US$) in Belgium in 2010 and the Value added (constant 2005 US$) in Jamaica in 2012?
Offer a very short reply. 2.70e+11. What is the difference between the Value added (constant 2005 US$) in Belgium in 2010 and the Value added (constant 2005 US$) in Macedonia in 2012?
Provide a short and direct response. 2.72e+11. What is the difference between the Value added (constant 2005 US$) in Belgium in 2010 and the Value added (constant 2005 US$) in Rwanda in 2012?
Provide a short and direct response. 2.74e+11. What is the difference between the Value added (constant 2005 US$) in Jamaica in 2010 and the Value added (constant 2005 US$) in Macedonia in 2012?
Provide a short and direct response. 2.68e+09. What is the difference between the Value added (constant 2005 US$) of Jamaica in 2010 and the Value added (constant 2005 US$) of Rwanda in 2012?
Give a very brief answer. 4.35e+09. What is the difference between the Value added (constant 2005 US$) in Macedonia in 2010 and the Value added (constant 2005 US$) in Rwanda in 2012?
Provide a short and direct response. 1.71e+09. What is the difference between the Value added (constant 2005 US$) of Belgium in 2010 and the Value added (constant 2005 US$) of Jamaica in 2013?
Offer a terse response. 2.70e+11. What is the difference between the Value added (constant 2005 US$) of Belgium in 2010 and the Value added (constant 2005 US$) of Macedonia in 2013?
Give a very brief answer. 2.72e+11. What is the difference between the Value added (constant 2005 US$) of Belgium in 2010 and the Value added (constant 2005 US$) of Rwanda in 2013?
Make the answer very short. 2.74e+11. What is the difference between the Value added (constant 2005 US$) of Jamaica in 2010 and the Value added (constant 2005 US$) of Macedonia in 2013?
Give a very brief answer. 2.56e+09. What is the difference between the Value added (constant 2005 US$) of Jamaica in 2010 and the Value added (constant 2005 US$) of Rwanda in 2013?
Ensure brevity in your answer.  4.22e+09. What is the difference between the Value added (constant 2005 US$) of Macedonia in 2010 and the Value added (constant 2005 US$) of Rwanda in 2013?
Your response must be concise. 1.58e+09. What is the difference between the Value added (constant 2005 US$) in Belgium in 2011 and the Value added (constant 2005 US$) in Jamaica in 2012?
Provide a succinct answer. 2.75e+11. What is the difference between the Value added (constant 2005 US$) of Belgium in 2011 and the Value added (constant 2005 US$) of Macedonia in 2012?
Your answer should be very brief. 2.78e+11. What is the difference between the Value added (constant 2005 US$) in Belgium in 2011 and the Value added (constant 2005 US$) in Rwanda in 2012?
Give a very brief answer. 2.80e+11. What is the difference between the Value added (constant 2005 US$) in Jamaica in 2011 and the Value added (constant 2005 US$) in Macedonia in 2012?
Provide a succinct answer. 2.69e+09. What is the difference between the Value added (constant 2005 US$) of Jamaica in 2011 and the Value added (constant 2005 US$) of Rwanda in 2012?
Your answer should be very brief. 4.37e+09. What is the difference between the Value added (constant 2005 US$) of Macedonia in 2011 and the Value added (constant 2005 US$) of Rwanda in 2012?
Your answer should be compact. 1.52e+09. What is the difference between the Value added (constant 2005 US$) of Belgium in 2011 and the Value added (constant 2005 US$) of Jamaica in 2013?
Offer a very short reply. 2.75e+11. What is the difference between the Value added (constant 2005 US$) of Belgium in 2011 and the Value added (constant 2005 US$) of Macedonia in 2013?
Your response must be concise. 2.78e+11. What is the difference between the Value added (constant 2005 US$) in Belgium in 2011 and the Value added (constant 2005 US$) in Rwanda in 2013?
Your answer should be very brief. 2.79e+11. What is the difference between the Value added (constant 2005 US$) in Jamaica in 2011 and the Value added (constant 2005 US$) in Macedonia in 2013?
Provide a succinct answer. 2.58e+09. What is the difference between the Value added (constant 2005 US$) in Jamaica in 2011 and the Value added (constant 2005 US$) in Rwanda in 2013?
Provide a succinct answer. 4.23e+09. What is the difference between the Value added (constant 2005 US$) of Macedonia in 2011 and the Value added (constant 2005 US$) of Rwanda in 2013?
Ensure brevity in your answer.  1.38e+09. What is the difference between the Value added (constant 2005 US$) in Belgium in 2012 and the Value added (constant 2005 US$) in Jamaica in 2013?
Provide a short and direct response. 2.76e+11. What is the difference between the Value added (constant 2005 US$) in Belgium in 2012 and the Value added (constant 2005 US$) in Macedonia in 2013?
Your response must be concise. 2.79e+11. What is the difference between the Value added (constant 2005 US$) in Belgium in 2012 and the Value added (constant 2005 US$) in Rwanda in 2013?
Provide a succinct answer. 2.81e+11. What is the difference between the Value added (constant 2005 US$) in Jamaica in 2012 and the Value added (constant 2005 US$) in Macedonia in 2013?
Give a very brief answer. 2.58e+09. What is the difference between the Value added (constant 2005 US$) of Jamaica in 2012 and the Value added (constant 2005 US$) of Rwanda in 2013?
Keep it short and to the point. 4.23e+09. What is the difference between the Value added (constant 2005 US$) in Macedonia in 2012 and the Value added (constant 2005 US$) in Rwanda in 2013?
Keep it short and to the point. 1.54e+09. What is the average Value added (constant 2005 US$) in Belgium per year?
Offer a very short reply. 2.75e+11. What is the average Value added (constant 2005 US$) in Jamaica per year?
Offer a very short reply. 7.03e+09. What is the average Value added (constant 2005 US$) in Macedonia per year?
Offer a terse response. 4.17e+09. What is the average Value added (constant 2005 US$) of Rwanda per year?
Make the answer very short. 2.11e+09. In the year 2006, what is the difference between the Value added (constant 2005 US$) of Belgium and Value added (constant 2005 US$) of Jamaica?
Your answer should be compact. 2.55e+11. In the year 2006, what is the difference between the Value added (constant 2005 US$) in Belgium and Value added (constant 2005 US$) in Macedonia?
Give a very brief answer. 2.58e+11. In the year 2006, what is the difference between the Value added (constant 2005 US$) in Belgium and Value added (constant 2005 US$) in Rwanda?
Offer a very short reply. 2.60e+11. In the year 2006, what is the difference between the Value added (constant 2005 US$) in Jamaica and Value added (constant 2005 US$) in Macedonia?
Give a very brief answer. 3.32e+09. In the year 2006, what is the difference between the Value added (constant 2005 US$) in Jamaica and Value added (constant 2005 US$) in Rwanda?
Ensure brevity in your answer.  5.49e+09. In the year 2006, what is the difference between the Value added (constant 2005 US$) of Macedonia and Value added (constant 2005 US$) of Rwanda?
Your answer should be compact. 2.17e+09. In the year 2007, what is the difference between the Value added (constant 2005 US$) in Belgium and Value added (constant 2005 US$) in Jamaica?
Your answer should be very brief. 2.63e+11. In the year 2007, what is the difference between the Value added (constant 2005 US$) of Belgium and Value added (constant 2005 US$) of Macedonia?
Offer a very short reply. 2.66e+11. In the year 2007, what is the difference between the Value added (constant 2005 US$) of Belgium and Value added (constant 2005 US$) of Rwanda?
Your response must be concise. 2.68e+11. In the year 2007, what is the difference between the Value added (constant 2005 US$) in Jamaica and Value added (constant 2005 US$) in Macedonia?
Offer a very short reply. 3.01e+09. In the year 2007, what is the difference between the Value added (constant 2005 US$) of Jamaica and Value added (constant 2005 US$) of Rwanda?
Provide a succinct answer. 5.47e+09. In the year 2007, what is the difference between the Value added (constant 2005 US$) in Macedonia and Value added (constant 2005 US$) in Rwanda?
Make the answer very short. 2.46e+09. In the year 2008, what is the difference between the Value added (constant 2005 US$) in Belgium and Value added (constant 2005 US$) in Jamaica?
Your response must be concise. 2.68e+11. In the year 2008, what is the difference between the Value added (constant 2005 US$) of Belgium and Value added (constant 2005 US$) of Macedonia?
Keep it short and to the point. 2.71e+11. In the year 2008, what is the difference between the Value added (constant 2005 US$) in Belgium and Value added (constant 2005 US$) in Rwanda?
Make the answer very short. 2.73e+11. In the year 2008, what is the difference between the Value added (constant 2005 US$) in Jamaica and Value added (constant 2005 US$) in Macedonia?
Keep it short and to the point. 2.90e+09. In the year 2008, what is the difference between the Value added (constant 2005 US$) in Jamaica and Value added (constant 2005 US$) in Rwanda?
Provide a succinct answer. 5.28e+09. In the year 2008, what is the difference between the Value added (constant 2005 US$) in Macedonia and Value added (constant 2005 US$) in Rwanda?
Offer a very short reply. 2.38e+09. In the year 2009, what is the difference between the Value added (constant 2005 US$) of Belgium and Value added (constant 2005 US$) of Jamaica?
Offer a very short reply. 2.65e+11. In the year 2009, what is the difference between the Value added (constant 2005 US$) in Belgium and Value added (constant 2005 US$) in Macedonia?
Your answer should be compact. 2.67e+11. In the year 2009, what is the difference between the Value added (constant 2005 US$) in Belgium and Value added (constant 2005 US$) in Rwanda?
Make the answer very short. 2.70e+11. In the year 2009, what is the difference between the Value added (constant 2005 US$) in Jamaica and Value added (constant 2005 US$) in Macedonia?
Your response must be concise. 2.92e+09. In the year 2009, what is the difference between the Value added (constant 2005 US$) of Jamaica and Value added (constant 2005 US$) of Rwanda?
Make the answer very short. 5.06e+09. In the year 2009, what is the difference between the Value added (constant 2005 US$) of Macedonia and Value added (constant 2005 US$) of Rwanda?
Offer a terse response. 2.14e+09. In the year 2010, what is the difference between the Value added (constant 2005 US$) of Belgium and Value added (constant 2005 US$) of Jamaica?
Give a very brief answer. 2.70e+11. In the year 2010, what is the difference between the Value added (constant 2005 US$) in Belgium and Value added (constant 2005 US$) in Macedonia?
Your response must be concise. 2.72e+11. In the year 2010, what is the difference between the Value added (constant 2005 US$) in Belgium and Value added (constant 2005 US$) in Rwanda?
Your answer should be compact. 2.74e+11. In the year 2010, what is the difference between the Value added (constant 2005 US$) in Jamaica and Value added (constant 2005 US$) in Macedonia?
Keep it short and to the point. 2.64e+09. In the year 2010, what is the difference between the Value added (constant 2005 US$) of Jamaica and Value added (constant 2005 US$) of Rwanda?
Keep it short and to the point. 4.81e+09. In the year 2010, what is the difference between the Value added (constant 2005 US$) in Macedonia and Value added (constant 2005 US$) in Rwanda?
Your answer should be very brief. 2.17e+09. In the year 2011, what is the difference between the Value added (constant 2005 US$) in Belgium and Value added (constant 2005 US$) in Jamaica?
Provide a short and direct response. 2.75e+11. In the year 2011, what is the difference between the Value added (constant 2005 US$) in Belgium and Value added (constant 2005 US$) in Macedonia?
Offer a terse response. 2.78e+11. In the year 2011, what is the difference between the Value added (constant 2005 US$) in Belgium and Value added (constant 2005 US$) in Rwanda?
Offer a terse response. 2.80e+11. In the year 2011, what is the difference between the Value added (constant 2005 US$) in Jamaica and Value added (constant 2005 US$) in Macedonia?
Your response must be concise. 2.85e+09. In the year 2011, what is the difference between the Value added (constant 2005 US$) of Jamaica and Value added (constant 2005 US$) of Rwanda?
Your answer should be very brief. 4.64e+09. In the year 2011, what is the difference between the Value added (constant 2005 US$) of Macedonia and Value added (constant 2005 US$) of Rwanda?
Provide a succinct answer. 1.79e+09. In the year 2012, what is the difference between the Value added (constant 2005 US$) in Belgium and Value added (constant 2005 US$) in Jamaica?
Your response must be concise. 2.76e+11. In the year 2012, what is the difference between the Value added (constant 2005 US$) in Belgium and Value added (constant 2005 US$) in Macedonia?
Offer a very short reply. 2.79e+11. In the year 2012, what is the difference between the Value added (constant 2005 US$) of Belgium and Value added (constant 2005 US$) of Rwanda?
Ensure brevity in your answer.  2.81e+11. In the year 2012, what is the difference between the Value added (constant 2005 US$) in Jamaica and Value added (constant 2005 US$) in Macedonia?
Offer a very short reply. 2.69e+09. In the year 2012, what is the difference between the Value added (constant 2005 US$) in Jamaica and Value added (constant 2005 US$) in Rwanda?
Ensure brevity in your answer.  4.37e+09. In the year 2012, what is the difference between the Value added (constant 2005 US$) in Macedonia and Value added (constant 2005 US$) in Rwanda?
Provide a short and direct response. 1.68e+09. In the year 2013, what is the difference between the Value added (constant 2005 US$) in Belgium and Value added (constant 2005 US$) in Jamaica?
Your answer should be very brief. 2.76e+11. In the year 2013, what is the difference between the Value added (constant 2005 US$) in Belgium and Value added (constant 2005 US$) in Macedonia?
Ensure brevity in your answer.  2.79e+11. In the year 2013, what is the difference between the Value added (constant 2005 US$) in Belgium and Value added (constant 2005 US$) in Rwanda?
Offer a terse response. 2.81e+11. In the year 2013, what is the difference between the Value added (constant 2005 US$) of Jamaica and Value added (constant 2005 US$) of Macedonia?
Your answer should be very brief. 2.59e+09. In the year 2013, what is the difference between the Value added (constant 2005 US$) in Jamaica and Value added (constant 2005 US$) in Rwanda?
Ensure brevity in your answer.  4.24e+09. In the year 2013, what is the difference between the Value added (constant 2005 US$) of Macedonia and Value added (constant 2005 US$) of Rwanda?
Offer a terse response. 1.65e+09. What is the ratio of the Value added (constant 2005 US$) of Belgium in 2006 to that in 2007?
Your answer should be very brief. 0.97. What is the ratio of the Value added (constant 2005 US$) of Jamaica in 2006 to that in 2007?
Make the answer very short. 0.98. What is the ratio of the Value added (constant 2005 US$) of Macedonia in 2006 to that in 2007?
Offer a very short reply. 0.89. What is the ratio of the Value added (constant 2005 US$) of Rwanda in 2006 to that in 2007?
Offer a very short reply. 0.89. What is the ratio of the Value added (constant 2005 US$) of Belgium in 2006 to that in 2008?
Provide a succinct answer. 0.95. What is the ratio of the Value added (constant 2005 US$) of Jamaica in 2006 to that in 2008?
Ensure brevity in your answer.  0.97. What is the ratio of the Value added (constant 2005 US$) of Macedonia in 2006 to that in 2008?
Provide a short and direct response. 0.86. What is the ratio of the Value added (constant 2005 US$) of Rwanda in 2006 to that in 2008?
Offer a very short reply. 0.79. What is the ratio of the Value added (constant 2005 US$) of Belgium in 2006 to that in 2009?
Keep it short and to the point. 0.96. What is the ratio of the Value added (constant 2005 US$) in Macedonia in 2006 to that in 2009?
Give a very brief answer. 0.88. What is the ratio of the Value added (constant 2005 US$) of Rwanda in 2006 to that in 2009?
Keep it short and to the point. 0.74. What is the ratio of the Value added (constant 2005 US$) of Belgium in 2006 to that in 2010?
Give a very brief answer. 0.95. What is the ratio of the Value added (constant 2005 US$) in Macedonia in 2006 to that in 2010?
Offer a terse response. 0.84. What is the ratio of the Value added (constant 2005 US$) of Rwanda in 2006 to that in 2010?
Offer a terse response. 0.68. What is the ratio of the Value added (constant 2005 US$) in Belgium in 2006 to that in 2011?
Your response must be concise. 0.93. What is the ratio of the Value added (constant 2005 US$) of Jamaica in 2006 to that in 2011?
Offer a terse response. 1. What is the ratio of the Value added (constant 2005 US$) of Macedonia in 2006 to that in 2011?
Provide a succinct answer. 0.88. What is the ratio of the Value added (constant 2005 US$) in Rwanda in 2006 to that in 2011?
Offer a terse response. 0.63. What is the ratio of the Value added (constant 2005 US$) in Belgium in 2006 to that in 2012?
Offer a terse response. 0.92. What is the ratio of the Value added (constant 2005 US$) of Macedonia in 2006 to that in 2012?
Your response must be concise. 0.85. What is the ratio of the Value added (constant 2005 US$) in Rwanda in 2006 to that in 2012?
Keep it short and to the point. 0.56. What is the ratio of the Value added (constant 2005 US$) of Belgium in 2006 to that in 2013?
Give a very brief answer. 0.92. What is the ratio of the Value added (constant 2005 US$) of Jamaica in 2006 to that in 2013?
Ensure brevity in your answer.  0.99. What is the ratio of the Value added (constant 2005 US$) in Macedonia in 2006 to that in 2013?
Your answer should be very brief. 0.83. What is the ratio of the Value added (constant 2005 US$) in Rwanda in 2006 to that in 2013?
Your answer should be compact. 0.53. What is the ratio of the Value added (constant 2005 US$) in Belgium in 2007 to that in 2008?
Offer a very short reply. 0.98. What is the ratio of the Value added (constant 2005 US$) of Jamaica in 2007 to that in 2008?
Provide a succinct answer. 1. What is the ratio of the Value added (constant 2005 US$) of Macedonia in 2007 to that in 2008?
Provide a succinct answer. 0.97. What is the ratio of the Value added (constant 2005 US$) in Rwanda in 2007 to that in 2008?
Keep it short and to the point. 0.88. What is the ratio of the Value added (constant 2005 US$) of Jamaica in 2007 to that in 2009?
Your answer should be compact. 1.01. What is the ratio of the Value added (constant 2005 US$) of Rwanda in 2007 to that in 2009?
Give a very brief answer. 0.83. What is the ratio of the Value added (constant 2005 US$) of Belgium in 2007 to that in 2010?
Offer a terse response. 0.98. What is the ratio of the Value added (constant 2005 US$) of Jamaica in 2007 to that in 2010?
Offer a terse response. 1.02. What is the ratio of the Value added (constant 2005 US$) in Macedonia in 2007 to that in 2010?
Make the answer very short. 0.95. What is the ratio of the Value added (constant 2005 US$) in Rwanda in 2007 to that in 2010?
Your response must be concise. 0.76. What is the ratio of the Value added (constant 2005 US$) in Belgium in 2007 to that in 2011?
Your answer should be very brief. 0.96. What is the ratio of the Value added (constant 2005 US$) of Jamaica in 2007 to that in 2011?
Provide a succinct answer. 1.02. What is the ratio of the Value added (constant 2005 US$) of Rwanda in 2007 to that in 2011?
Provide a short and direct response. 0.7. What is the ratio of the Value added (constant 2005 US$) in Belgium in 2007 to that in 2012?
Your answer should be compact. 0.95. What is the ratio of the Value added (constant 2005 US$) in Jamaica in 2007 to that in 2012?
Provide a succinct answer. 1.02. What is the ratio of the Value added (constant 2005 US$) in Macedonia in 2007 to that in 2012?
Your answer should be very brief. 0.96. What is the ratio of the Value added (constant 2005 US$) in Rwanda in 2007 to that in 2012?
Ensure brevity in your answer.  0.63. What is the ratio of the Value added (constant 2005 US$) of Belgium in 2007 to that in 2013?
Keep it short and to the point. 0.95. What is the ratio of the Value added (constant 2005 US$) of Jamaica in 2007 to that in 2013?
Ensure brevity in your answer.  1.02. What is the ratio of the Value added (constant 2005 US$) in Macedonia in 2007 to that in 2013?
Your answer should be very brief. 0.93. What is the ratio of the Value added (constant 2005 US$) of Rwanda in 2007 to that in 2013?
Offer a terse response. 0.6. What is the ratio of the Value added (constant 2005 US$) in Belgium in 2008 to that in 2009?
Give a very brief answer. 1.01. What is the ratio of the Value added (constant 2005 US$) of Jamaica in 2008 to that in 2009?
Your answer should be very brief. 1.01. What is the ratio of the Value added (constant 2005 US$) in Rwanda in 2008 to that in 2009?
Your response must be concise. 0.94. What is the ratio of the Value added (constant 2005 US$) of Jamaica in 2008 to that in 2010?
Your response must be concise. 1.02. What is the ratio of the Value added (constant 2005 US$) in Macedonia in 2008 to that in 2010?
Provide a short and direct response. 0.98. What is the ratio of the Value added (constant 2005 US$) of Rwanda in 2008 to that in 2010?
Give a very brief answer. 0.86. What is the ratio of the Value added (constant 2005 US$) of Belgium in 2008 to that in 2011?
Provide a short and direct response. 0.97. What is the ratio of the Value added (constant 2005 US$) of Jamaica in 2008 to that in 2011?
Provide a succinct answer. 1.02. What is the ratio of the Value added (constant 2005 US$) in Macedonia in 2008 to that in 2011?
Ensure brevity in your answer.  1.03. What is the ratio of the Value added (constant 2005 US$) in Rwanda in 2008 to that in 2011?
Provide a succinct answer. 0.8. What is the ratio of the Value added (constant 2005 US$) of Belgium in 2008 to that in 2012?
Make the answer very short. 0.97. What is the ratio of the Value added (constant 2005 US$) of Jamaica in 2008 to that in 2012?
Keep it short and to the point. 1.02. What is the ratio of the Value added (constant 2005 US$) of Macedonia in 2008 to that in 2012?
Provide a succinct answer. 0.99. What is the ratio of the Value added (constant 2005 US$) in Rwanda in 2008 to that in 2012?
Give a very brief answer. 0.71. What is the ratio of the Value added (constant 2005 US$) of Belgium in 2008 to that in 2013?
Offer a very short reply. 0.97. What is the ratio of the Value added (constant 2005 US$) in Jamaica in 2008 to that in 2013?
Your answer should be compact. 1.02. What is the ratio of the Value added (constant 2005 US$) of Rwanda in 2008 to that in 2013?
Make the answer very short. 0.68. What is the ratio of the Value added (constant 2005 US$) of Belgium in 2009 to that in 2010?
Your answer should be very brief. 0.98. What is the ratio of the Value added (constant 2005 US$) of Jamaica in 2009 to that in 2010?
Keep it short and to the point. 1.01. What is the ratio of the Value added (constant 2005 US$) of Macedonia in 2009 to that in 2010?
Provide a succinct answer. 0.95. What is the ratio of the Value added (constant 2005 US$) in Rwanda in 2009 to that in 2010?
Ensure brevity in your answer.  0.92. What is the ratio of the Value added (constant 2005 US$) in Belgium in 2009 to that in 2011?
Make the answer very short. 0.96. What is the ratio of the Value added (constant 2005 US$) of Jamaica in 2009 to that in 2011?
Provide a short and direct response. 1.01. What is the ratio of the Value added (constant 2005 US$) of Rwanda in 2009 to that in 2011?
Your response must be concise. 0.85. What is the ratio of the Value added (constant 2005 US$) of Belgium in 2009 to that in 2012?
Ensure brevity in your answer.  0.96. What is the ratio of the Value added (constant 2005 US$) of Jamaica in 2009 to that in 2012?
Provide a succinct answer. 1.01. What is the ratio of the Value added (constant 2005 US$) of Macedonia in 2009 to that in 2012?
Your answer should be compact. 0.96. What is the ratio of the Value added (constant 2005 US$) of Rwanda in 2009 to that in 2012?
Ensure brevity in your answer.  0.76. What is the ratio of the Value added (constant 2005 US$) in Belgium in 2009 to that in 2013?
Your answer should be very brief. 0.96. What is the ratio of the Value added (constant 2005 US$) of Macedonia in 2009 to that in 2013?
Give a very brief answer. 0.94. What is the ratio of the Value added (constant 2005 US$) of Rwanda in 2009 to that in 2013?
Make the answer very short. 0.72. What is the ratio of the Value added (constant 2005 US$) of Belgium in 2010 to that in 2011?
Offer a terse response. 0.98. What is the ratio of the Value added (constant 2005 US$) in Macedonia in 2010 to that in 2011?
Your answer should be very brief. 1.05. What is the ratio of the Value added (constant 2005 US$) in Rwanda in 2010 to that in 2011?
Provide a short and direct response. 0.92. What is the ratio of the Value added (constant 2005 US$) of Belgium in 2010 to that in 2012?
Keep it short and to the point. 0.98. What is the ratio of the Value added (constant 2005 US$) in Jamaica in 2010 to that in 2012?
Give a very brief answer. 1. What is the ratio of the Value added (constant 2005 US$) in Macedonia in 2010 to that in 2012?
Make the answer very short. 1.01. What is the ratio of the Value added (constant 2005 US$) of Rwanda in 2010 to that in 2012?
Provide a short and direct response. 0.83. What is the ratio of the Value added (constant 2005 US$) of Belgium in 2010 to that in 2013?
Provide a short and direct response. 0.98. What is the ratio of the Value added (constant 2005 US$) in Jamaica in 2010 to that in 2013?
Offer a terse response. 1. What is the ratio of the Value added (constant 2005 US$) of Macedonia in 2010 to that in 2013?
Provide a succinct answer. 0.98. What is the ratio of the Value added (constant 2005 US$) in Rwanda in 2010 to that in 2013?
Keep it short and to the point. 0.79. What is the ratio of the Value added (constant 2005 US$) of Macedonia in 2011 to that in 2012?
Give a very brief answer. 0.96. What is the ratio of the Value added (constant 2005 US$) of Rwanda in 2011 to that in 2012?
Ensure brevity in your answer.  0.9. What is the ratio of the Value added (constant 2005 US$) of Jamaica in 2011 to that in 2013?
Your answer should be compact. 1. What is the ratio of the Value added (constant 2005 US$) in Macedonia in 2011 to that in 2013?
Your answer should be compact. 0.94. What is the ratio of the Value added (constant 2005 US$) in Rwanda in 2011 to that in 2013?
Offer a terse response. 0.85. What is the ratio of the Value added (constant 2005 US$) in Belgium in 2012 to that in 2013?
Provide a succinct answer. 1. What is the ratio of the Value added (constant 2005 US$) of Jamaica in 2012 to that in 2013?
Offer a very short reply. 1. What is the ratio of the Value added (constant 2005 US$) in Macedonia in 2012 to that in 2013?
Your response must be concise. 0.97. What is the ratio of the Value added (constant 2005 US$) of Rwanda in 2012 to that in 2013?
Your response must be concise. 0.95. What is the difference between the highest and the second highest Value added (constant 2005 US$) in Belgium?
Your response must be concise. 2.04e+07. What is the difference between the highest and the second highest Value added (constant 2005 US$) of Jamaica?
Ensure brevity in your answer.  2.92e+07. What is the difference between the highest and the second highest Value added (constant 2005 US$) of Macedonia?
Provide a succinct answer. 7.68e+07. What is the difference between the highest and the second highest Value added (constant 2005 US$) in Rwanda?
Give a very brief answer. 1.37e+08. What is the difference between the highest and the lowest Value added (constant 2005 US$) of Belgium?
Provide a succinct answer. 2.18e+1. What is the difference between the highest and the lowest Value added (constant 2005 US$) of Jamaica?
Make the answer very short. 1.85e+08. What is the difference between the highest and the lowest Value added (constant 2005 US$) of Macedonia?
Give a very brief answer. 7.69e+08. What is the difference between the highest and the lowest Value added (constant 2005 US$) of Rwanda?
Provide a succinct answer. 1.29e+09. 